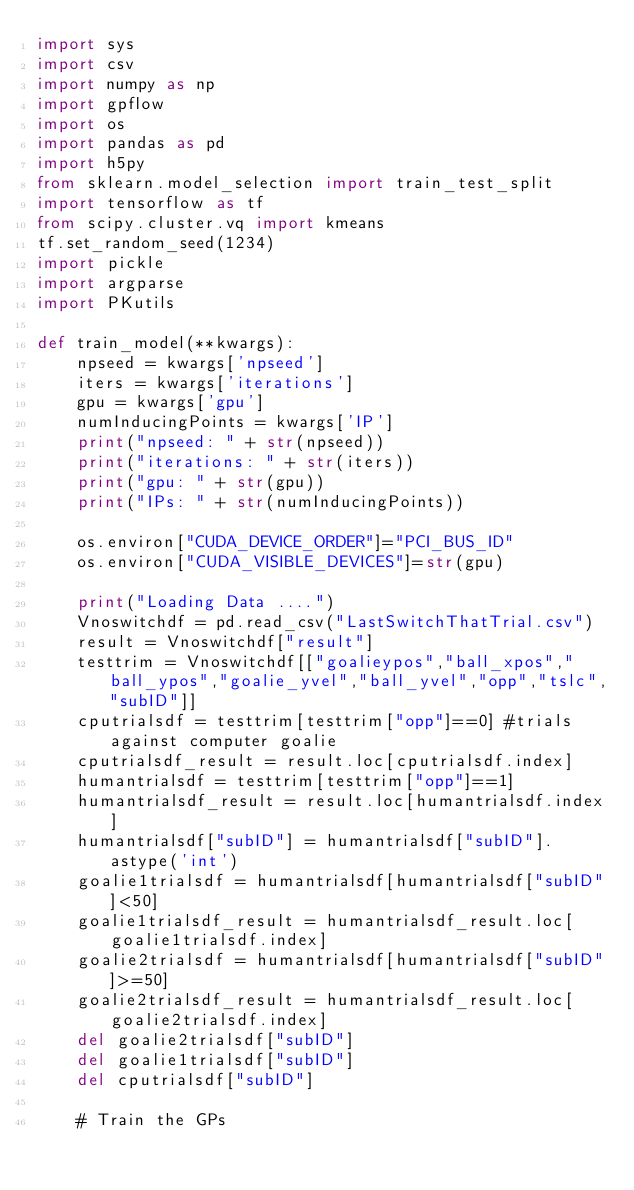Convert code to text. <code><loc_0><loc_0><loc_500><loc_500><_Python_>import sys
import csv
import numpy as np
import gpflow
import os
import pandas as pd
import h5py
from sklearn.model_selection import train_test_split
import tensorflow as tf
from scipy.cluster.vq import kmeans
tf.set_random_seed(1234)
import pickle
import argparse
import PKutils

def train_model(**kwargs):
	npseed = kwargs['npseed']
	iters = kwargs['iterations']
	gpu = kwargs['gpu']
	numInducingPoints = kwargs['IP']
	print("npseed: " + str(npseed))
	print("iterations: " + str(iters))
	print("gpu: " + str(gpu))
	print("IPs: " + str(numInducingPoints))

	os.environ["CUDA_DEVICE_ORDER"]="PCI_BUS_ID"
	os.environ["CUDA_VISIBLE_DEVICES"]=str(gpu)

	print("Loading Data ....")
	Vnoswitchdf = pd.read_csv("LastSwitchThatTrial.csv")
	result = Vnoswitchdf["result"]
	testtrim = Vnoswitchdf[["goalieypos","ball_xpos","ball_ypos","goalie_yvel","ball_yvel","opp","tslc","subID"]]
	cputrialsdf = testtrim[testtrim["opp"]==0] #trials against computer goalie
	cputrialsdf_result = result.loc[cputrialsdf.index]
	humantrialsdf = testtrim[testtrim["opp"]==1]
	humantrialsdf_result = result.loc[humantrialsdf.index]
	humantrialsdf["subID"] = humantrialsdf["subID"].astype('int')
	goalie1trialsdf = humantrialsdf[humantrialsdf["subID"]<50]
	goalie1trialsdf_result = humantrialsdf_result.loc[goalie1trialsdf.index]
	goalie2trialsdf = humantrialsdf[humantrialsdf["subID"]>=50]
	goalie2trialsdf_result = humantrialsdf_result.loc[goalie2trialsdf.index]
	del goalie2trialsdf["subID"]
	del goalie1trialsdf["subID"]
	del cputrialsdf["subID"]

	# Train the GPs</code> 